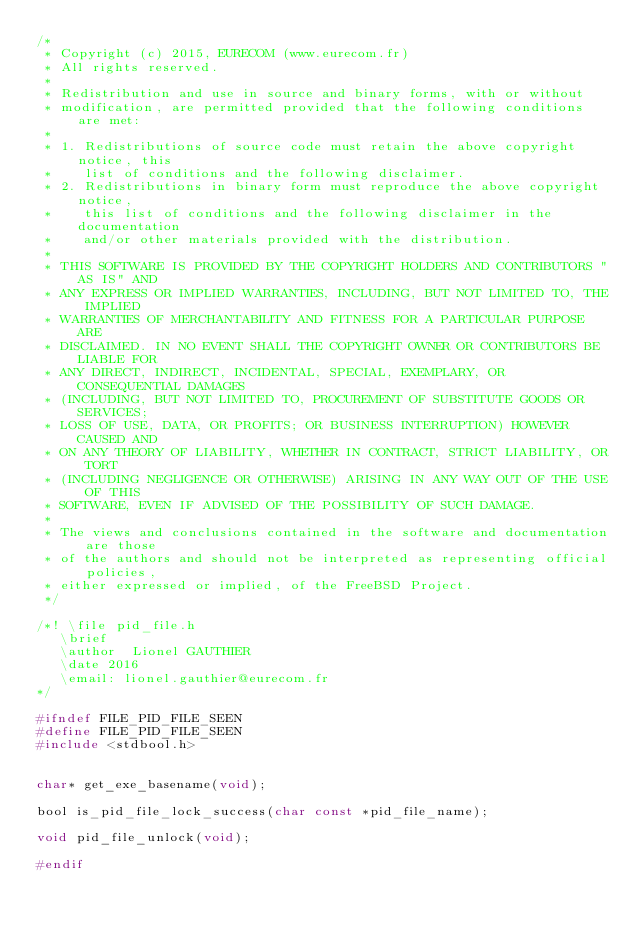Convert code to text. <code><loc_0><loc_0><loc_500><loc_500><_C_>/*
 * Copyright (c) 2015, EURECOM (www.eurecom.fr)
 * All rights reserved.
 *
 * Redistribution and use in source and binary forms, with or without
 * modification, are permitted provided that the following conditions are met:
 *
 * 1. Redistributions of source code must retain the above copyright notice, this
 *    list of conditions and the following disclaimer.
 * 2. Redistributions in binary form must reproduce the above copyright notice,
 *    this list of conditions and the following disclaimer in the documentation
 *    and/or other materials provided with the distribution.
 *
 * THIS SOFTWARE IS PROVIDED BY THE COPYRIGHT HOLDERS AND CONTRIBUTORS "AS IS" AND
 * ANY EXPRESS OR IMPLIED WARRANTIES, INCLUDING, BUT NOT LIMITED TO, THE IMPLIED
 * WARRANTIES OF MERCHANTABILITY AND FITNESS FOR A PARTICULAR PURPOSE ARE
 * DISCLAIMED. IN NO EVENT SHALL THE COPYRIGHT OWNER OR CONTRIBUTORS BE LIABLE FOR
 * ANY DIRECT, INDIRECT, INCIDENTAL, SPECIAL, EXEMPLARY, OR CONSEQUENTIAL DAMAGES
 * (INCLUDING, BUT NOT LIMITED TO, PROCUREMENT OF SUBSTITUTE GOODS OR SERVICES;
 * LOSS OF USE, DATA, OR PROFITS; OR BUSINESS INTERRUPTION) HOWEVER CAUSED AND
 * ON ANY THEORY OF LIABILITY, WHETHER IN CONTRACT, STRICT LIABILITY, OR TORT
 * (INCLUDING NEGLIGENCE OR OTHERWISE) ARISING IN ANY WAY OUT OF THE USE OF THIS
 * SOFTWARE, EVEN IF ADVISED OF THE POSSIBILITY OF SUCH DAMAGE.
 *
 * The views and conclusions contained in the software and documentation are those
 * of the authors and should not be interpreted as representing official policies,
 * either expressed or implied, of the FreeBSD Project.
 */

/*! \file pid_file.h
   \brief
   \author  Lionel GAUTHIER
   \date 2016
   \email: lionel.gauthier@eurecom.fr
*/

#ifndef FILE_PID_FILE_SEEN
#define FILE_PID_FILE_SEEN
#include <stdbool.h>


char* get_exe_basename(void);

bool is_pid_file_lock_success(char const *pid_file_name);

void pid_file_unlock(void);

#endif
</code> 